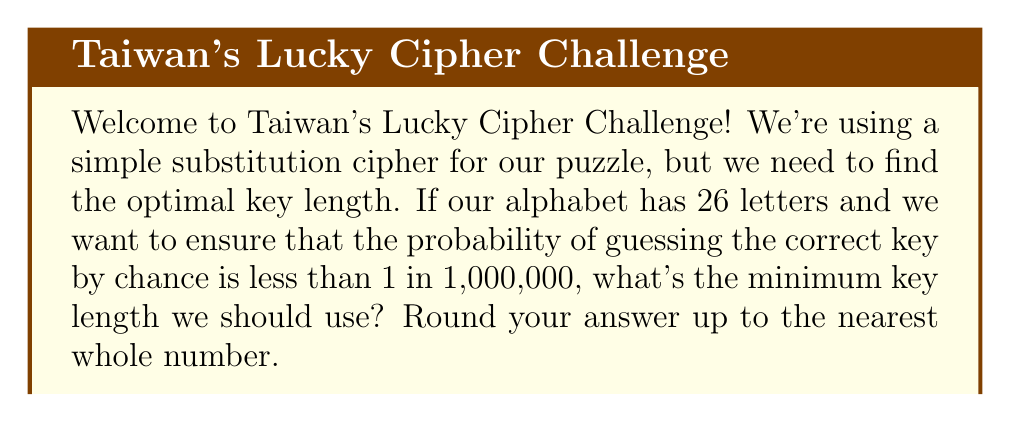Can you solve this math problem? Let's approach this step-by-step:

1) In a simple substitution cipher, each letter is replaced by another letter. The key length determines how many unique substitutions we use.

2) With a key length of $n$, we have $26^n$ possible keys, as each position in the key can be any of the 26 letters.

3) We want the probability of guessing the correct key to be less than 1 in 1,000,000. Mathematically, this means:

   $\frac{1}{26^n} < \frac{1}{1,000,000}$

4) We can solve this inequality:

   $26^n > 1,000,000$

5) Taking the logarithm of both sides:

   $n \log(26) > \log(1,000,000)$

6) Solving for $n$:

   $n > \frac{\log(1,000,000)}{\log(26)}$

7) Calculating this:

   $n > \frac{6}{1.4149} \approx 4.2405$

8) Since $n$ must be a whole number, and we're asked to round up, our final answer is 5.
Answer: 5 